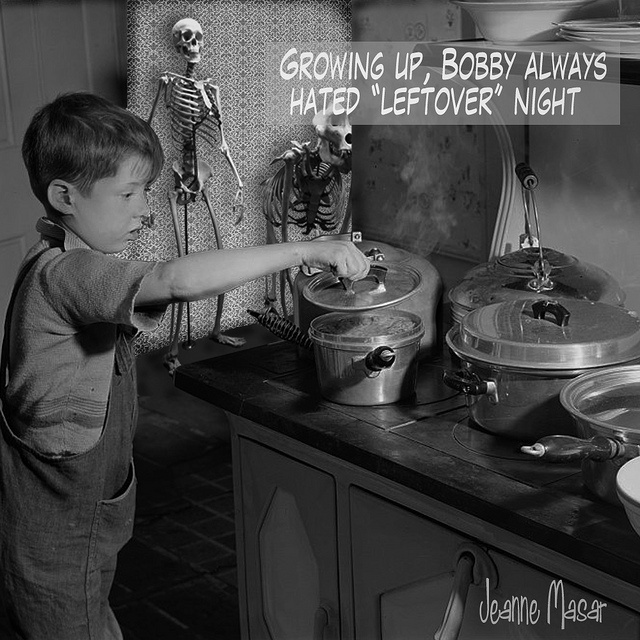Describe the objects in this image and their specific colors. I can see people in black, gray, darkgray, and lightgray tones, oven in black, gray, darkgray, and lightgray tones, bowl in gray, black, and darkgray tones, and bowl in black, darkgray, gray, and lightgray tones in this image. 